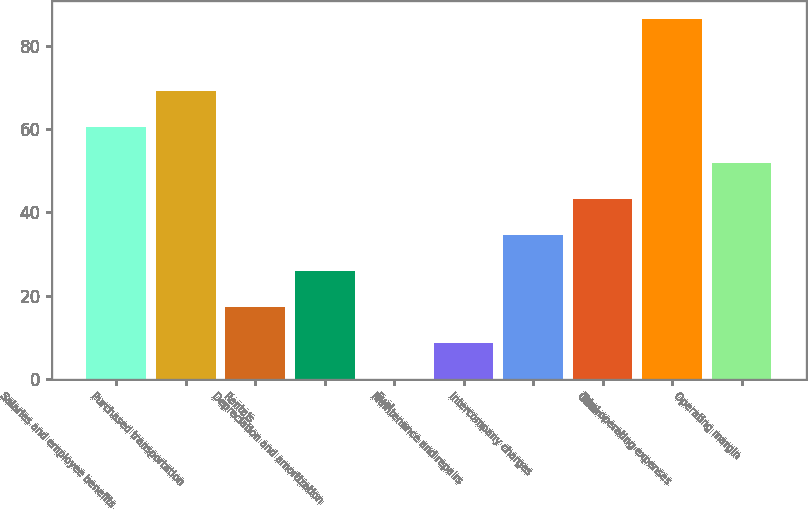Convert chart. <chart><loc_0><loc_0><loc_500><loc_500><bar_chart><fcel>Salaries and employee benefits<fcel>Purchased transportation<fcel>Rentals<fcel>Depreciation and amortization<fcel>Fuel<fcel>Maintenance and repairs<fcel>Intercompany charges<fcel>Other<fcel>Total operating expenses<fcel>Operating margin<nl><fcel>60.54<fcel>69.16<fcel>17.44<fcel>26.06<fcel>0.2<fcel>8.82<fcel>34.68<fcel>43.3<fcel>86.4<fcel>51.92<nl></chart> 